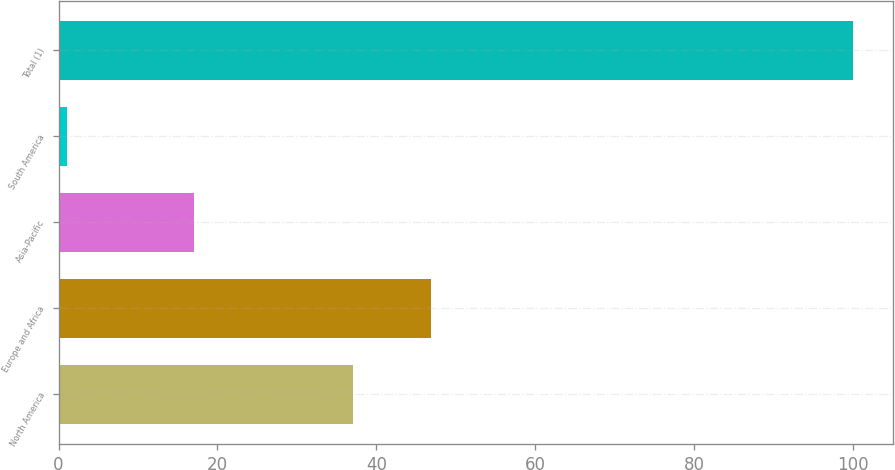<chart> <loc_0><loc_0><loc_500><loc_500><bar_chart><fcel>North America<fcel>Europe and Africa<fcel>Asia-Pacific<fcel>South America<fcel>Total (1)<nl><fcel>37<fcel>46.9<fcel>17<fcel>1<fcel>100<nl></chart> 